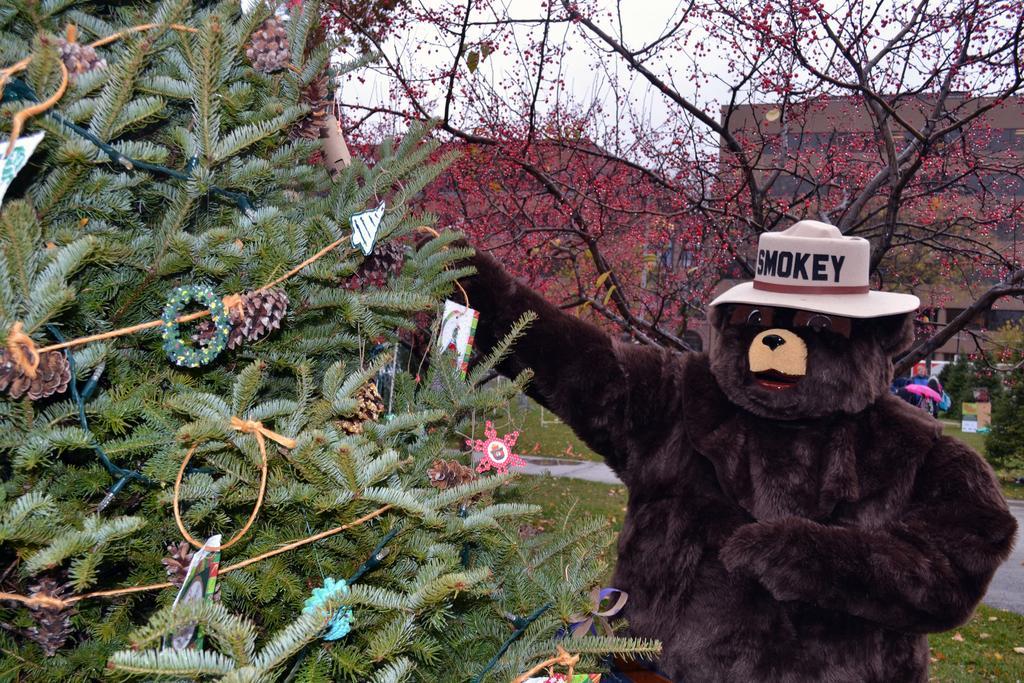Describe this image in one or two sentences. In this picture there is a person with bear costume. At the back there are buildings and trees and there is a board. On the left side of the image there is a Christmas tree. At the top there is sky. At the bottom there is grass and there is a road. 